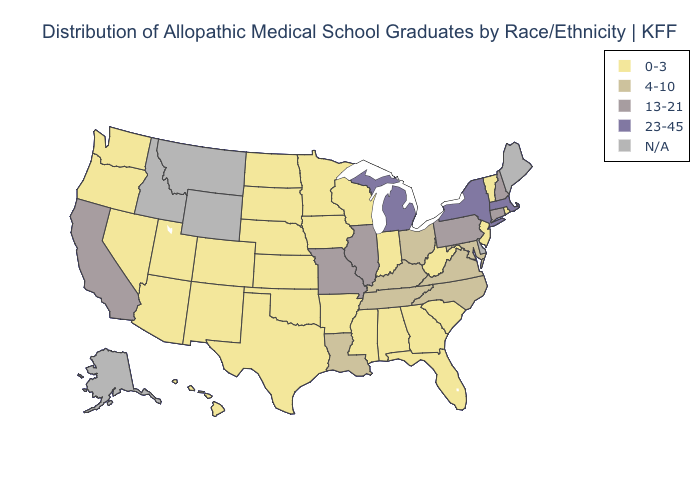Name the states that have a value in the range 23-45?
Write a very short answer. Massachusetts, Michigan, New York. What is the value of Mississippi?
Keep it brief. 0-3. What is the lowest value in states that border South Carolina?
Concise answer only. 0-3. What is the highest value in states that border Georgia?
Short answer required. 4-10. What is the lowest value in states that border Alabama?
Short answer required. 0-3. What is the lowest value in the MidWest?
Concise answer only. 0-3. What is the highest value in the West ?
Short answer required. 13-21. Does the first symbol in the legend represent the smallest category?
Write a very short answer. Yes. What is the value of Oklahoma?
Write a very short answer. 0-3. Does New York have the lowest value in the USA?
Concise answer only. No. Which states have the lowest value in the USA?
Be succinct. Alabama, Arizona, Arkansas, Colorado, Florida, Georgia, Hawaii, Indiana, Iowa, Kansas, Minnesota, Mississippi, Nebraska, Nevada, New Jersey, New Mexico, North Dakota, Oklahoma, Oregon, Rhode Island, South Carolina, South Dakota, Texas, Utah, Vermont, Washington, West Virginia, Wisconsin. What is the highest value in the West ?
Keep it brief. 13-21. What is the value of Oklahoma?
Give a very brief answer. 0-3. 